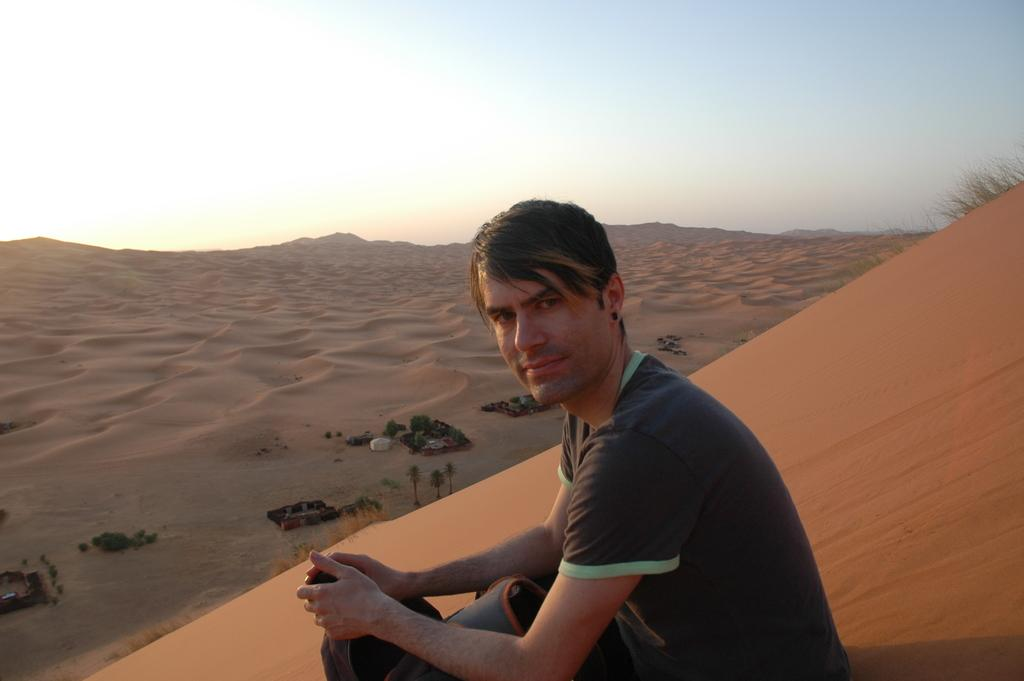What is the man sitting on in the image? The man is sitting on sand in the image. What is the man holding in his hand? The man is holding an object in the image. What can be seen in the background of the image? There is sand, trees, and the sky visible in the background of the image. What is the purpose of the man's mouth in the image? There is no information about the man's mouth in the image, so we cannot determine its purpose. 